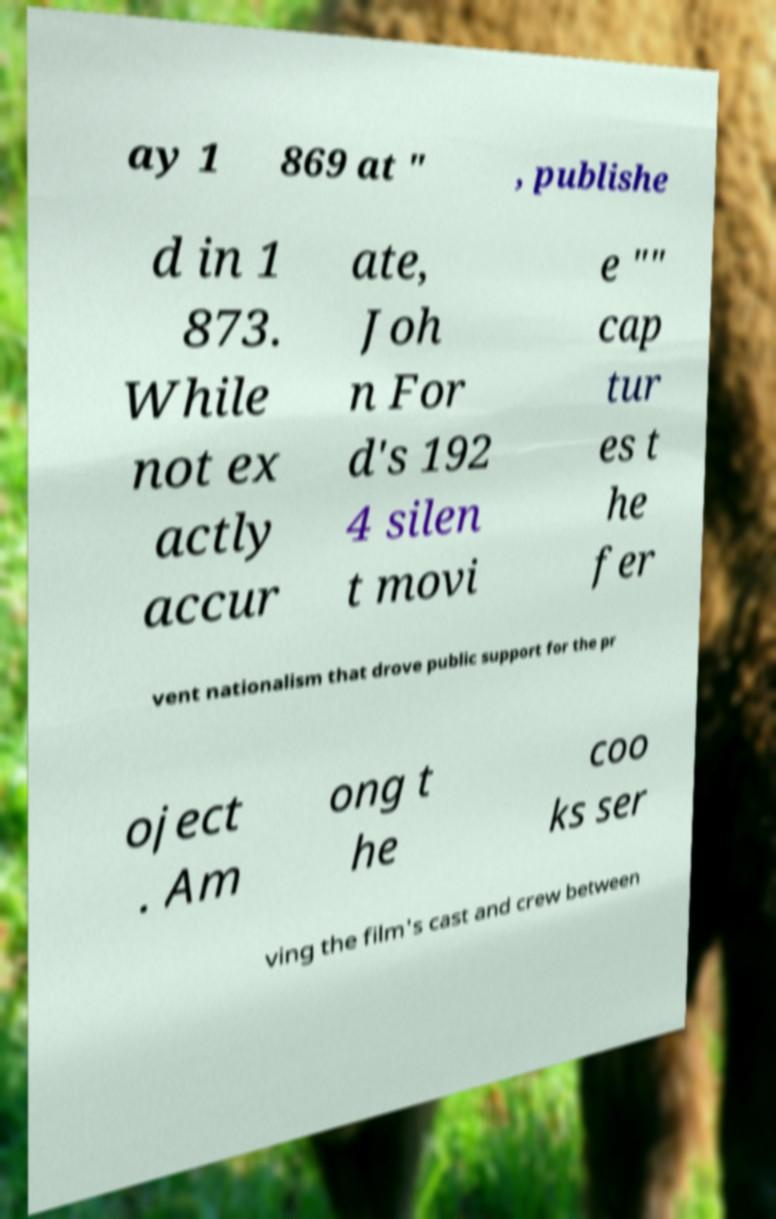What messages or text are displayed in this image? I need them in a readable, typed format. ay 1 869 at " , publishe d in 1 873. While not ex actly accur ate, Joh n For d's 192 4 silen t movi e "" cap tur es t he fer vent nationalism that drove public support for the pr oject . Am ong t he coo ks ser ving the film's cast and crew between 